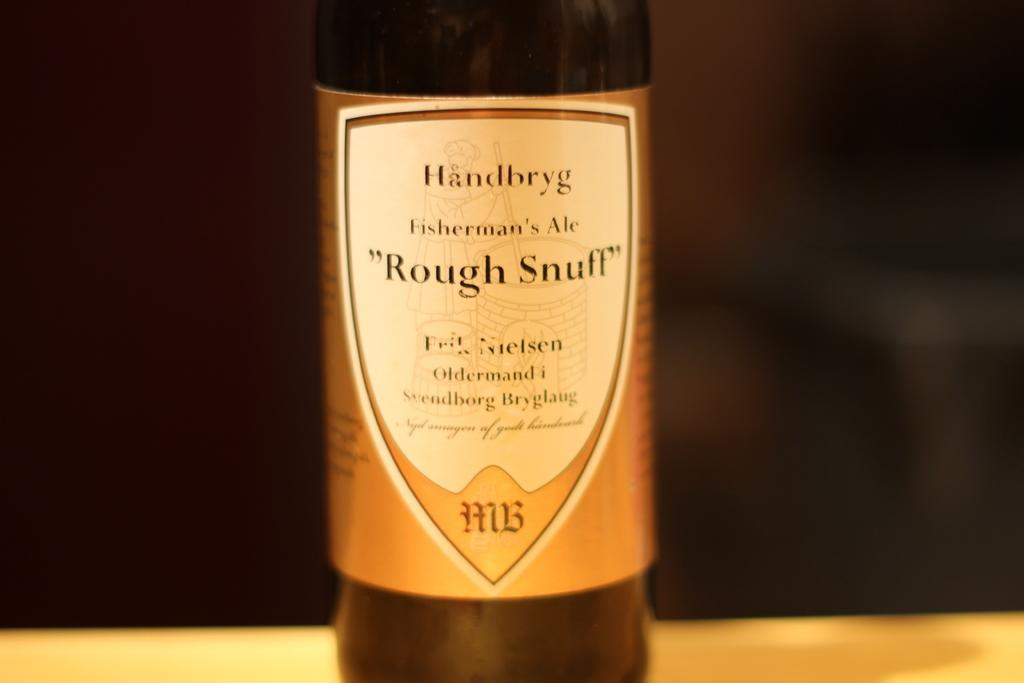<image>
Present a compact description of the photo's key features. A bottle of Fisherman's Ale called Rough Snuff. 